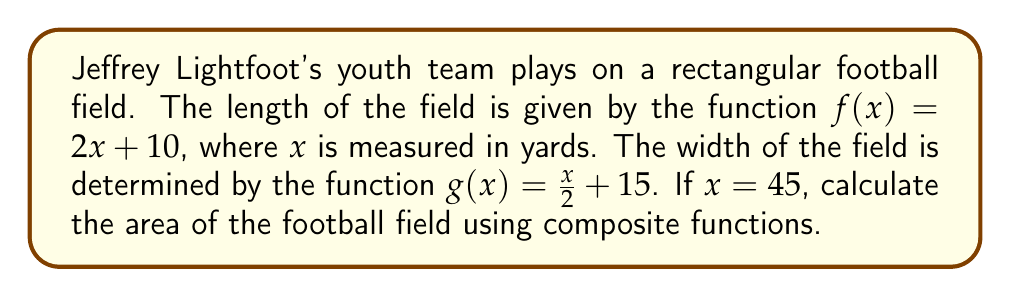Solve this math problem. Let's approach this step-by-step:

1) We need to find the length and width of the field using the given functions.

2) For the length, we use $f(x) = 2x + 10$:
   $f(45) = 2(45) + 10 = 90 + 10 = 100$ yards

3) For the width, we use $g(x) = \frac{x}{2} + 15$:
   $g(45) = \frac{45}{2} + 15 = 22.5 + 15 = 37.5$ yards

4) Now, we need to create a composite function to calculate the area. The area of a rectangle is length times width, so we can define:

   $A(x) = f(x) \cdot g(x)$

5) Substituting our functions:

   $A(x) = (2x + 10) \cdot (\frac{x}{2} + 15)$

6) Now, let's calculate $A(45)$:

   $A(45) = (2(45) + 10) \cdot (\frac{45}{2} + 15)$
   $= 100 \cdot 37.5$
   $= 3750$

7) Therefore, the area of the football field is 3750 square yards.
Answer: 3750 square yards 